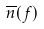Convert formula to latex. <formula><loc_0><loc_0><loc_500><loc_500>\overline { n } ( f )</formula> 